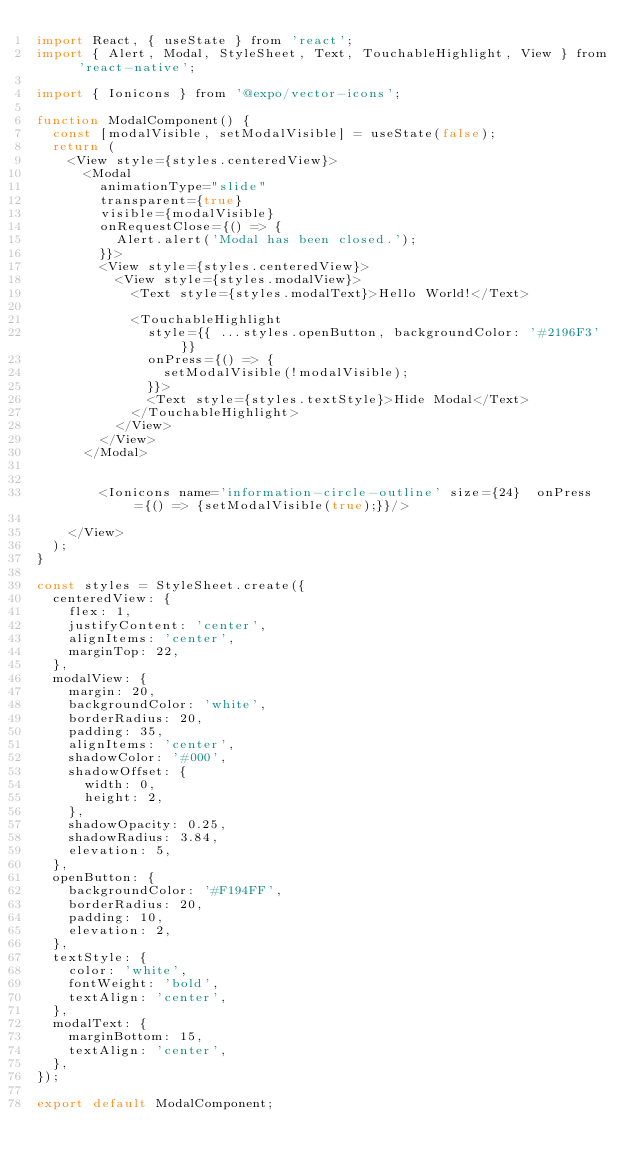Convert code to text. <code><loc_0><loc_0><loc_500><loc_500><_JavaScript_>import React, { useState } from 'react';
import { Alert, Modal, StyleSheet, Text, TouchableHighlight, View } from 'react-native';

import { Ionicons } from '@expo/vector-icons';

function ModalComponent() {
  const [modalVisible, setModalVisible] = useState(false);
  return (
    <View style={styles.centeredView}>
      <Modal
        animationType="slide"
        transparent={true}
        visible={modalVisible}
        onRequestClose={() => {
          Alert.alert('Modal has been closed.');
        }}>
        <View style={styles.centeredView}>
          <View style={styles.modalView}>
            <Text style={styles.modalText}>Hello World!</Text>

            <TouchableHighlight
              style={{ ...styles.openButton, backgroundColor: '#2196F3' }}
              onPress={() => {
                setModalVisible(!modalVisible);
              }}>
              <Text style={styles.textStyle}>Hide Modal</Text>
            </TouchableHighlight>
          </View>
        </View>
      </Modal>

  
        <Ionicons name='information-circle-outline' size={24}  onPress={() => {setModalVisible(true);}}/>

    </View>
  );
}

const styles = StyleSheet.create({
  centeredView: {
    flex: 1,
    justifyContent: 'center',
    alignItems: 'center',
    marginTop: 22,
  },
  modalView: {
    margin: 20,
    backgroundColor: 'white',
    borderRadius: 20,
    padding: 35,
    alignItems: 'center',
    shadowColor: '#000',
    shadowOffset: {
      width: 0,
      height: 2,
    },
    shadowOpacity: 0.25,
    shadowRadius: 3.84,
    elevation: 5,
  },
  openButton: {
    backgroundColor: '#F194FF',
    borderRadius: 20,
    padding: 10,
    elevation: 2,
  },
  textStyle: {
    color: 'white',
    fontWeight: 'bold',
    textAlign: 'center',
  },
  modalText: {
    marginBottom: 15,
    textAlign: 'center',
  },
});

export default ModalComponent;</code> 